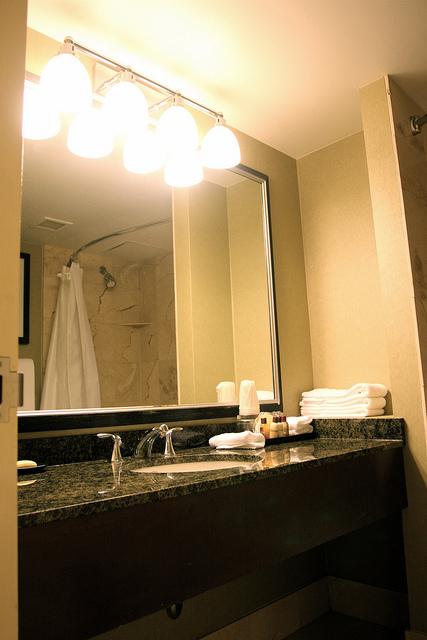What room is this?
Short answer required. Bathroom. What color is the backsplash in sink area?
Short answer required. Black. How many lights are there?
Be succinct. 4. What is reflected in the mirror?
Give a very brief answer. Shower. What's behind the sink?
Give a very brief answer. Mirror. Why are the lights on?
Keep it brief. To see. 